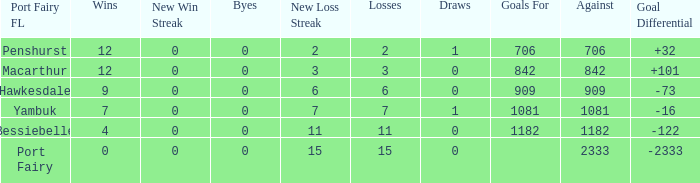Write the full table. {'header': ['Port Fairy FL', 'Wins', 'New Win Streak', 'Byes', 'New Loss Streak', 'Losses', 'Draws', 'Goals For', 'Against', 'Goal Differential'], 'rows': [['Penshurst', '12', '0', '0', '2', '2', '1', '706', '706', '+32'], ['Macarthur', '12', '0', '0', '3', '3', '0', '842', '842', '+101'], ['Hawkesdale', '9', '0', '0', '6', '6', '0', '909', '909', '-73'], ['Yambuk', '7', '0', '0', '7', '7', '1', '1081', '1081', '-16'], ['Bessiebelle', '4', '0', '0', '11', '11', '0', '1182', '1182', '-122'], ['Port Fairy', '0', '0', '0', '15', '15', '0', '', '2333', '-2333']]} How many byes when the draws are less than 0? 0.0. 